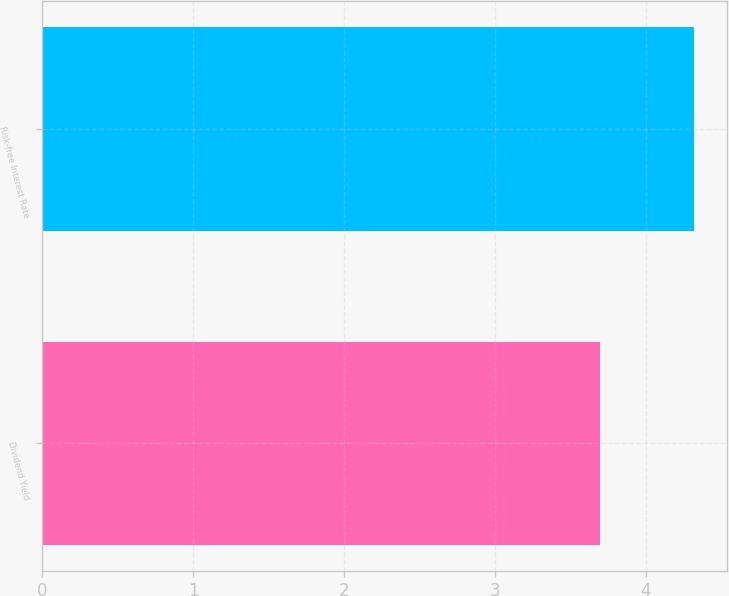Convert chart to OTSL. <chart><loc_0><loc_0><loc_500><loc_500><bar_chart><fcel>Dividend Yield<fcel>Risk-free Interest Rate<nl><fcel>3.7<fcel>4.32<nl></chart> 